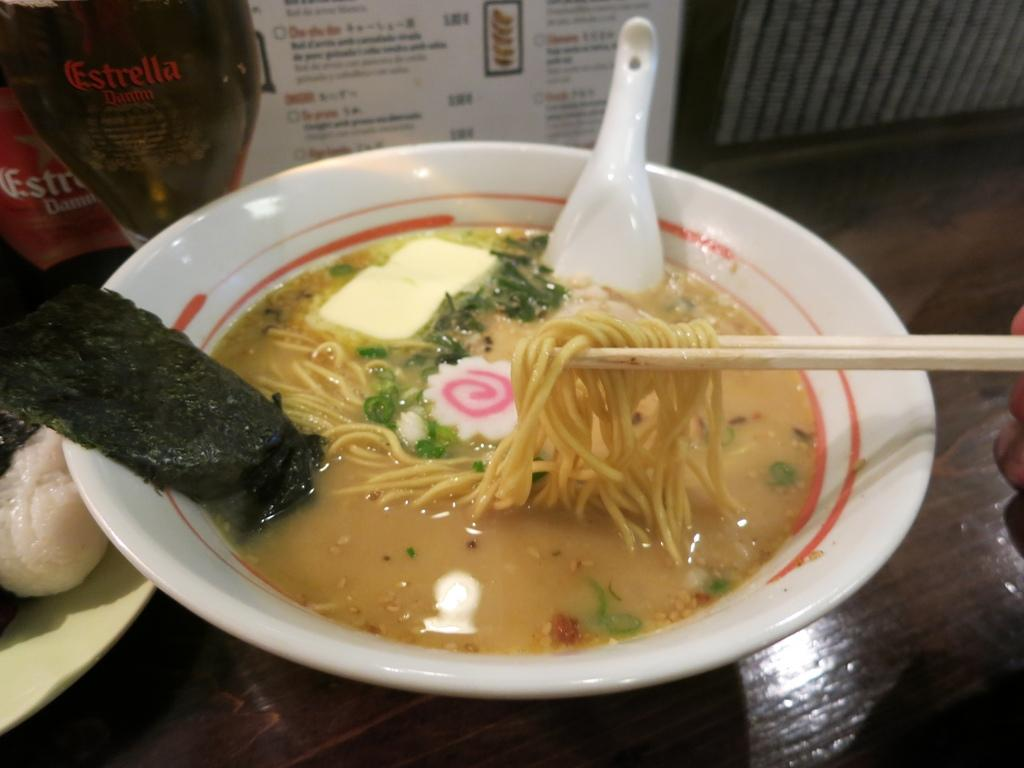What type of food is visible in the image? There are noodles and soup in the image. What utensils are present in the image? There is a spoon and chopsticks in the image. What is the dish used to serve the noodles and soup? There is a bowl in the image. What else can be seen on the table in the image? There is a glass and a bottle on the table in the image. What type of vase is present on the table in the image? There is no vase present on the table in the image. What details can be seen on the chopsticks in the image? The provided facts do not mention any specific details about the chopsticks, so we cannot answer this question definitively. 